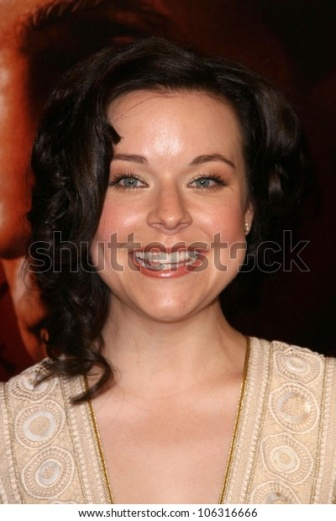Can you tell me what's happening in this image? Certainly! In this image, we see a woman who is most likely attending a glamorous event, such as a red carpet occasion. She is dressed elegantly in a beige dress with circular patterns and is smiling joyfully. The blurred red background suggests a lively, exciting atmosphere, possibly filled with other attendees and media coverage. Why do you think she looks so happy? Her joyful expression suggests that she is having a great time at the event. She might be happy because she is enjoying the spotlight, meeting other people, or feeling confident in her beautiful attire. Being part of such an event can naturally bring a lot of excitement and joy. 